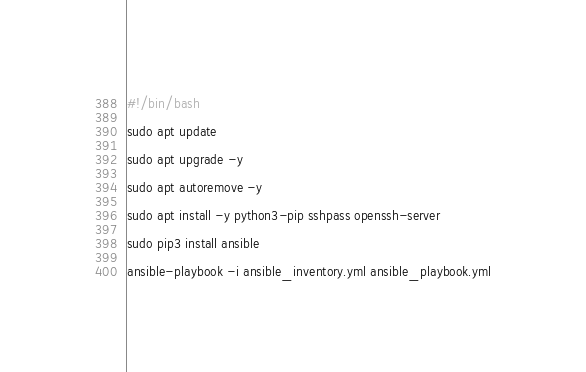<code> <loc_0><loc_0><loc_500><loc_500><_Bash_>#!/bin/bash

sudo apt update

sudo apt upgrade -y

sudo apt autoremove -y

sudo apt install -y python3-pip sshpass openssh-server

sudo pip3 install ansible

ansible-playbook -i ansible_inventory.yml ansible_playbook.yml</code> 